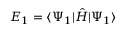<formula> <loc_0><loc_0><loc_500><loc_500>E _ { 1 } = { \langle \Psi _ { 1 } | } \hat { H } { | \Psi _ { 1 } \rangle }</formula> 